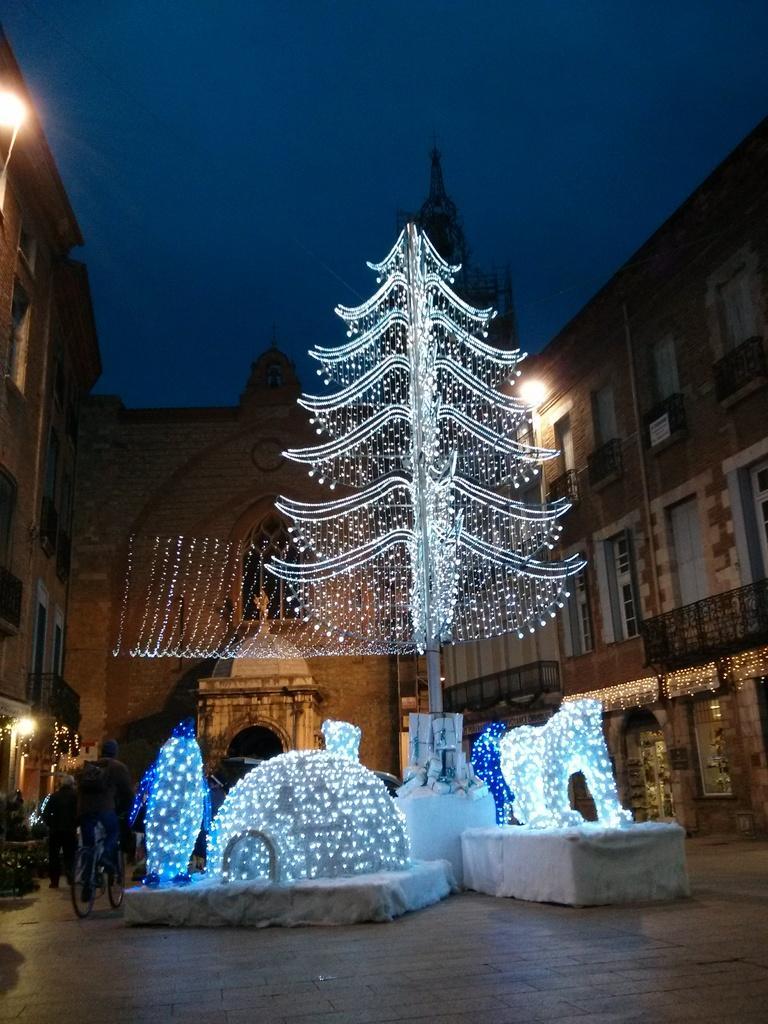Could you give a brief overview of what you see in this image? In this image there is a person riding a bicycle, beside the person there is another person walking, beside them there are some objects and a Christmas tree decorated with lights, around them there are buildings with lights. 